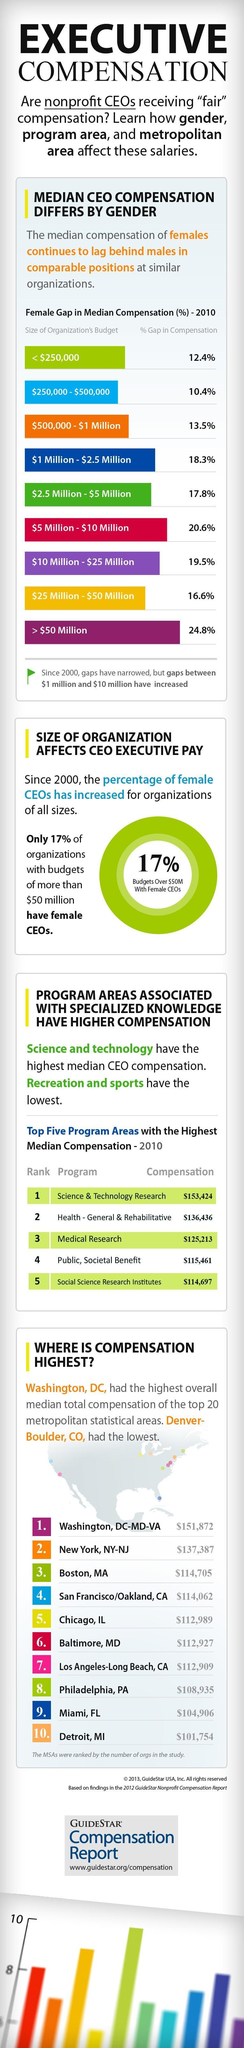What is the inverse number of Women CEOs in companies with a wealth of higher than a 50million?
Answer the question with a short phrase. 83 What is the size of the organization for which female gap compensation is second highest? $5 Million - $10 Million What is the size of the organization for which female gap compensation is fourth highest? $1 Million - $2.5 Million Which program area has the third-highest compensation in dollars? Medical Research How much is the decrease in the median salary for women working in the second biggest organization? 16.6% Which program area has the second-highest compensation in dollars? Health - General & Rehabilitative How much is the median salary for women working in the third-lowest budget organization? 13.5% 